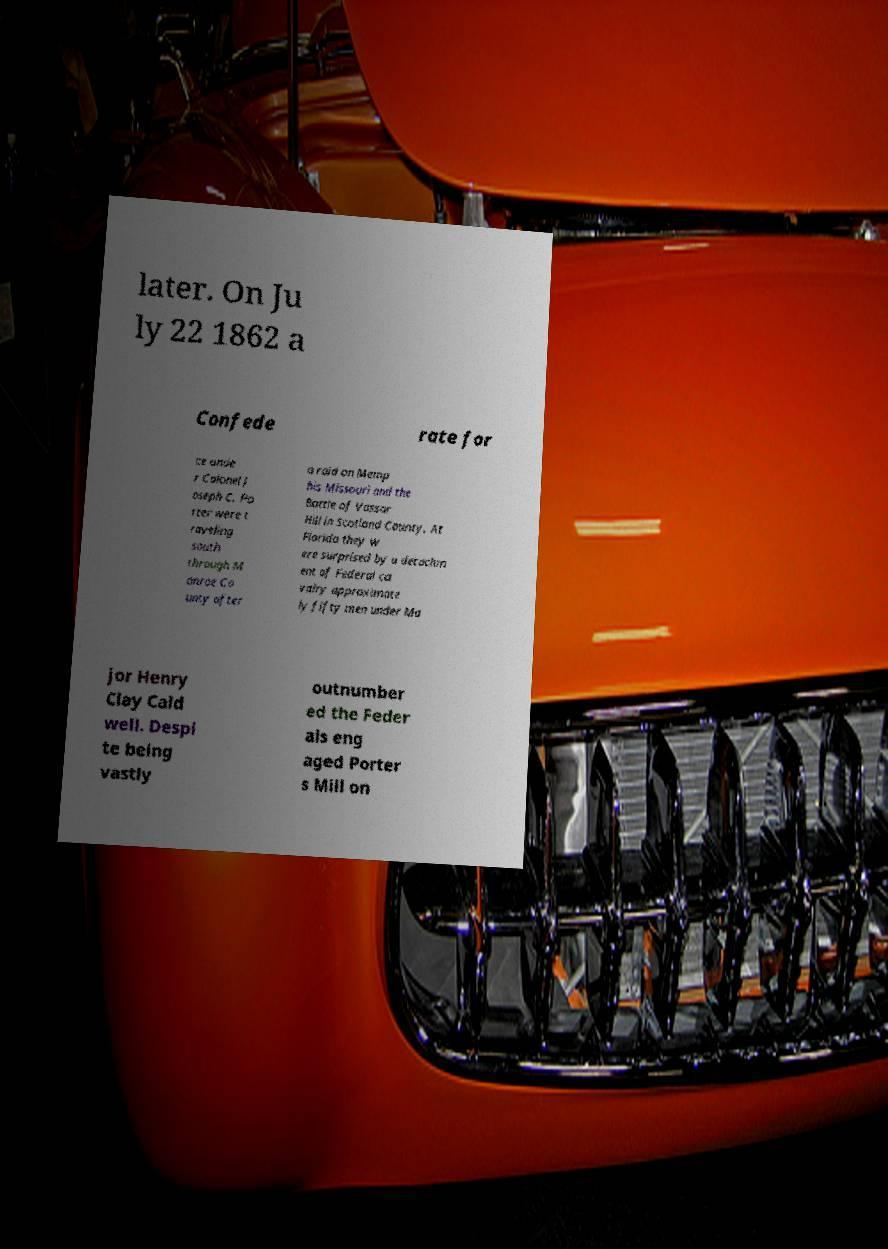Please identify and transcribe the text found in this image. later. On Ju ly 22 1862 a Confede rate for ce unde r Colonel J oseph C. Po rter were t raveling south through M onroe Co unty after a raid on Memp his Missouri and the Battle of Vassar Hill in Scotland County. At Florida they w ere surprised by a detachm ent of Federal ca valry approximate ly fifty men under Ma jor Henry Clay Cald well. Despi te being vastly outnumber ed the Feder als eng aged Porter s Mill on 